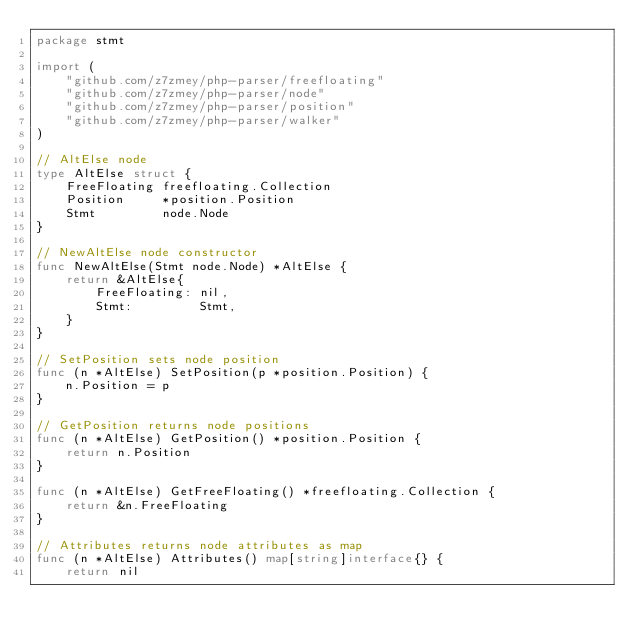<code> <loc_0><loc_0><loc_500><loc_500><_Go_>package stmt

import (
	"github.com/z7zmey/php-parser/freefloating"
	"github.com/z7zmey/php-parser/node"
	"github.com/z7zmey/php-parser/position"
	"github.com/z7zmey/php-parser/walker"
)

// AltElse node
type AltElse struct {
	FreeFloating freefloating.Collection
	Position     *position.Position
	Stmt         node.Node
}

// NewAltElse node constructor
func NewAltElse(Stmt node.Node) *AltElse {
	return &AltElse{
		FreeFloating: nil,
		Stmt:         Stmt,
	}
}

// SetPosition sets node position
func (n *AltElse) SetPosition(p *position.Position) {
	n.Position = p
}

// GetPosition returns node positions
func (n *AltElse) GetPosition() *position.Position {
	return n.Position
}

func (n *AltElse) GetFreeFloating() *freefloating.Collection {
	return &n.FreeFloating
}

// Attributes returns node attributes as map
func (n *AltElse) Attributes() map[string]interface{} {
	return nil</code> 